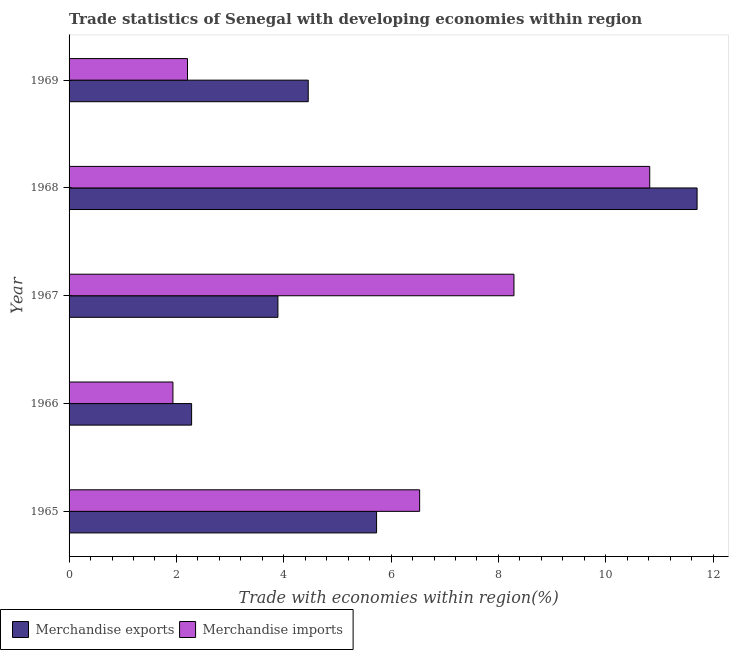How many groups of bars are there?
Give a very brief answer. 5. Are the number of bars per tick equal to the number of legend labels?
Your answer should be compact. Yes. How many bars are there on the 3rd tick from the bottom?
Provide a succinct answer. 2. What is the label of the 5th group of bars from the top?
Provide a succinct answer. 1965. What is the merchandise imports in 1965?
Ensure brevity in your answer.  6.53. Across all years, what is the maximum merchandise exports?
Your answer should be very brief. 11.7. Across all years, what is the minimum merchandise exports?
Offer a terse response. 2.28. In which year was the merchandise imports maximum?
Make the answer very short. 1968. In which year was the merchandise imports minimum?
Provide a succinct answer. 1966. What is the total merchandise imports in the graph?
Your answer should be very brief. 29.78. What is the difference between the merchandise imports in 1966 and that in 1968?
Make the answer very short. -8.88. What is the difference between the merchandise exports in 1966 and the merchandise imports in 1968?
Offer a terse response. -8.54. What is the average merchandise imports per year?
Ensure brevity in your answer.  5.96. In the year 1966, what is the difference between the merchandise exports and merchandise imports?
Ensure brevity in your answer.  0.35. What is the ratio of the merchandise exports in 1965 to that in 1966?
Offer a terse response. 2.51. What is the difference between the highest and the second highest merchandise imports?
Keep it short and to the point. 2.53. What is the difference between the highest and the lowest merchandise imports?
Your answer should be compact. 8.88. In how many years, is the merchandise exports greater than the average merchandise exports taken over all years?
Your answer should be compact. 2. Is the sum of the merchandise exports in 1966 and 1969 greater than the maximum merchandise imports across all years?
Make the answer very short. No. How many bars are there?
Give a very brief answer. 10. Does the graph contain grids?
Offer a very short reply. No. How are the legend labels stacked?
Provide a short and direct response. Horizontal. What is the title of the graph?
Make the answer very short. Trade statistics of Senegal with developing economies within region. Does "Lowest 10% of population" appear as one of the legend labels in the graph?
Keep it short and to the point. No. What is the label or title of the X-axis?
Make the answer very short. Trade with economies within region(%). What is the Trade with economies within region(%) of Merchandise exports in 1965?
Ensure brevity in your answer.  5.73. What is the Trade with economies within region(%) in Merchandise imports in 1965?
Give a very brief answer. 6.53. What is the Trade with economies within region(%) of Merchandise exports in 1966?
Your answer should be very brief. 2.28. What is the Trade with economies within region(%) in Merchandise imports in 1966?
Give a very brief answer. 1.94. What is the Trade with economies within region(%) of Merchandise exports in 1967?
Your answer should be compact. 3.89. What is the Trade with economies within region(%) of Merchandise imports in 1967?
Give a very brief answer. 8.29. What is the Trade with economies within region(%) of Merchandise exports in 1968?
Provide a short and direct response. 11.7. What is the Trade with economies within region(%) of Merchandise imports in 1968?
Your answer should be very brief. 10.82. What is the Trade with economies within region(%) of Merchandise exports in 1969?
Offer a terse response. 4.46. What is the Trade with economies within region(%) of Merchandise imports in 1969?
Your answer should be compact. 2.21. Across all years, what is the maximum Trade with economies within region(%) of Merchandise exports?
Your answer should be compact. 11.7. Across all years, what is the maximum Trade with economies within region(%) of Merchandise imports?
Ensure brevity in your answer.  10.82. Across all years, what is the minimum Trade with economies within region(%) in Merchandise exports?
Make the answer very short. 2.28. Across all years, what is the minimum Trade with economies within region(%) of Merchandise imports?
Your answer should be very brief. 1.94. What is the total Trade with economies within region(%) in Merchandise exports in the graph?
Provide a short and direct response. 28.06. What is the total Trade with economies within region(%) of Merchandise imports in the graph?
Give a very brief answer. 29.78. What is the difference between the Trade with economies within region(%) in Merchandise exports in 1965 and that in 1966?
Ensure brevity in your answer.  3.45. What is the difference between the Trade with economies within region(%) in Merchandise imports in 1965 and that in 1966?
Make the answer very short. 4.6. What is the difference between the Trade with economies within region(%) in Merchandise exports in 1965 and that in 1967?
Offer a very short reply. 1.84. What is the difference between the Trade with economies within region(%) in Merchandise imports in 1965 and that in 1967?
Provide a short and direct response. -1.76. What is the difference between the Trade with economies within region(%) in Merchandise exports in 1965 and that in 1968?
Your response must be concise. -5.97. What is the difference between the Trade with economies within region(%) of Merchandise imports in 1965 and that in 1968?
Provide a succinct answer. -4.29. What is the difference between the Trade with economies within region(%) of Merchandise exports in 1965 and that in 1969?
Keep it short and to the point. 1.27. What is the difference between the Trade with economies within region(%) of Merchandise imports in 1965 and that in 1969?
Offer a terse response. 4.33. What is the difference between the Trade with economies within region(%) in Merchandise exports in 1966 and that in 1967?
Offer a terse response. -1.61. What is the difference between the Trade with economies within region(%) in Merchandise imports in 1966 and that in 1967?
Give a very brief answer. -6.35. What is the difference between the Trade with economies within region(%) in Merchandise exports in 1966 and that in 1968?
Provide a short and direct response. -9.42. What is the difference between the Trade with economies within region(%) in Merchandise imports in 1966 and that in 1968?
Offer a terse response. -8.88. What is the difference between the Trade with economies within region(%) of Merchandise exports in 1966 and that in 1969?
Provide a succinct answer. -2.17. What is the difference between the Trade with economies within region(%) of Merchandise imports in 1966 and that in 1969?
Provide a succinct answer. -0.27. What is the difference between the Trade with economies within region(%) in Merchandise exports in 1967 and that in 1968?
Keep it short and to the point. -7.81. What is the difference between the Trade with economies within region(%) in Merchandise imports in 1967 and that in 1968?
Give a very brief answer. -2.53. What is the difference between the Trade with economies within region(%) in Merchandise exports in 1967 and that in 1969?
Your answer should be compact. -0.56. What is the difference between the Trade with economies within region(%) in Merchandise imports in 1967 and that in 1969?
Offer a terse response. 6.08. What is the difference between the Trade with economies within region(%) in Merchandise exports in 1968 and that in 1969?
Offer a terse response. 7.25. What is the difference between the Trade with economies within region(%) in Merchandise imports in 1968 and that in 1969?
Your answer should be very brief. 8.61. What is the difference between the Trade with economies within region(%) in Merchandise exports in 1965 and the Trade with economies within region(%) in Merchandise imports in 1966?
Provide a short and direct response. 3.79. What is the difference between the Trade with economies within region(%) of Merchandise exports in 1965 and the Trade with economies within region(%) of Merchandise imports in 1967?
Your answer should be compact. -2.56. What is the difference between the Trade with economies within region(%) in Merchandise exports in 1965 and the Trade with economies within region(%) in Merchandise imports in 1968?
Your answer should be compact. -5.09. What is the difference between the Trade with economies within region(%) of Merchandise exports in 1965 and the Trade with economies within region(%) of Merchandise imports in 1969?
Make the answer very short. 3.52. What is the difference between the Trade with economies within region(%) in Merchandise exports in 1966 and the Trade with economies within region(%) in Merchandise imports in 1967?
Keep it short and to the point. -6.01. What is the difference between the Trade with economies within region(%) of Merchandise exports in 1966 and the Trade with economies within region(%) of Merchandise imports in 1968?
Offer a terse response. -8.54. What is the difference between the Trade with economies within region(%) in Merchandise exports in 1966 and the Trade with economies within region(%) in Merchandise imports in 1969?
Your answer should be very brief. 0.08. What is the difference between the Trade with economies within region(%) of Merchandise exports in 1967 and the Trade with economies within region(%) of Merchandise imports in 1968?
Provide a succinct answer. -6.93. What is the difference between the Trade with economies within region(%) in Merchandise exports in 1967 and the Trade with economies within region(%) in Merchandise imports in 1969?
Your answer should be very brief. 1.68. What is the difference between the Trade with economies within region(%) of Merchandise exports in 1968 and the Trade with economies within region(%) of Merchandise imports in 1969?
Provide a succinct answer. 9.5. What is the average Trade with economies within region(%) in Merchandise exports per year?
Make the answer very short. 5.61. What is the average Trade with economies within region(%) of Merchandise imports per year?
Your answer should be very brief. 5.96. In the year 1965, what is the difference between the Trade with economies within region(%) of Merchandise exports and Trade with economies within region(%) of Merchandise imports?
Give a very brief answer. -0.8. In the year 1966, what is the difference between the Trade with economies within region(%) of Merchandise exports and Trade with economies within region(%) of Merchandise imports?
Keep it short and to the point. 0.35. In the year 1967, what is the difference between the Trade with economies within region(%) of Merchandise exports and Trade with economies within region(%) of Merchandise imports?
Offer a terse response. -4.4. In the year 1968, what is the difference between the Trade with economies within region(%) in Merchandise exports and Trade with economies within region(%) in Merchandise imports?
Provide a short and direct response. 0.88. In the year 1969, what is the difference between the Trade with economies within region(%) in Merchandise exports and Trade with economies within region(%) in Merchandise imports?
Make the answer very short. 2.25. What is the ratio of the Trade with economies within region(%) of Merchandise exports in 1965 to that in 1966?
Offer a very short reply. 2.51. What is the ratio of the Trade with economies within region(%) of Merchandise imports in 1965 to that in 1966?
Make the answer very short. 3.38. What is the ratio of the Trade with economies within region(%) in Merchandise exports in 1965 to that in 1967?
Offer a terse response. 1.47. What is the ratio of the Trade with economies within region(%) in Merchandise imports in 1965 to that in 1967?
Offer a terse response. 0.79. What is the ratio of the Trade with economies within region(%) in Merchandise exports in 1965 to that in 1968?
Ensure brevity in your answer.  0.49. What is the ratio of the Trade with economies within region(%) in Merchandise imports in 1965 to that in 1968?
Provide a short and direct response. 0.6. What is the ratio of the Trade with economies within region(%) of Merchandise imports in 1965 to that in 1969?
Your answer should be compact. 2.96. What is the ratio of the Trade with economies within region(%) in Merchandise exports in 1966 to that in 1967?
Your answer should be compact. 0.59. What is the ratio of the Trade with economies within region(%) in Merchandise imports in 1966 to that in 1967?
Offer a terse response. 0.23. What is the ratio of the Trade with economies within region(%) in Merchandise exports in 1966 to that in 1968?
Provide a short and direct response. 0.2. What is the ratio of the Trade with economies within region(%) of Merchandise imports in 1966 to that in 1968?
Your answer should be very brief. 0.18. What is the ratio of the Trade with economies within region(%) in Merchandise exports in 1966 to that in 1969?
Make the answer very short. 0.51. What is the ratio of the Trade with economies within region(%) of Merchandise imports in 1966 to that in 1969?
Your answer should be compact. 0.88. What is the ratio of the Trade with economies within region(%) of Merchandise exports in 1967 to that in 1968?
Your answer should be compact. 0.33. What is the ratio of the Trade with economies within region(%) of Merchandise imports in 1967 to that in 1968?
Your response must be concise. 0.77. What is the ratio of the Trade with economies within region(%) of Merchandise exports in 1967 to that in 1969?
Provide a short and direct response. 0.87. What is the ratio of the Trade with economies within region(%) in Merchandise imports in 1967 to that in 1969?
Offer a terse response. 3.76. What is the ratio of the Trade with economies within region(%) in Merchandise exports in 1968 to that in 1969?
Offer a very short reply. 2.63. What is the ratio of the Trade with economies within region(%) of Merchandise imports in 1968 to that in 1969?
Your answer should be very brief. 4.9. What is the difference between the highest and the second highest Trade with economies within region(%) of Merchandise exports?
Your answer should be compact. 5.97. What is the difference between the highest and the second highest Trade with economies within region(%) of Merchandise imports?
Your answer should be very brief. 2.53. What is the difference between the highest and the lowest Trade with economies within region(%) in Merchandise exports?
Your answer should be compact. 9.42. What is the difference between the highest and the lowest Trade with economies within region(%) of Merchandise imports?
Ensure brevity in your answer.  8.88. 